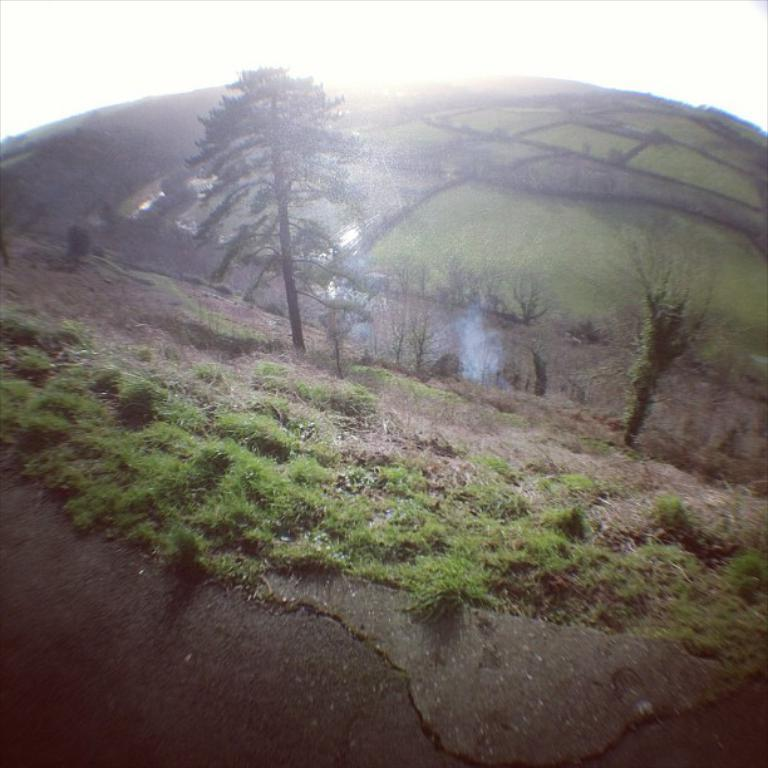What type of vegetation is present on the ground in the image? There is grass on the ground in the image. What other natural elements can be seen in the image? There are trees visible in the image. What is visible in the background of the image? The sky is visible in the background of the image. Where is the son playing with the ball in the image? There is no son or ball present in the image; it only features grass, trees, and the sky. 